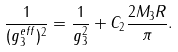Convert formula to latex. <formula><loc_0><loc_0><loc_500><loc_500>\frac { 1 } { ( g _ { 3 } ^ { e f f } ) ^ { 2 } } = \frac { 1 } { g _ { 3 } ^ { 2 } } + C _ { 2 } \frac { 2 M _ { 3 } R } { \pi } .</formula> 